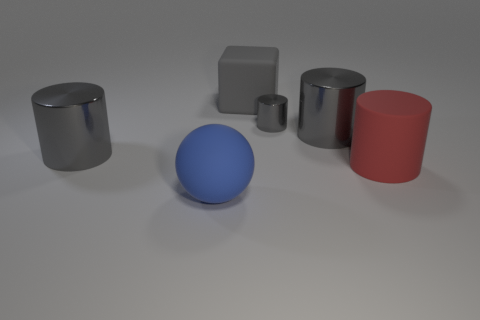Imagine these objects were part of a child's toy set. How would you envision their use? In a child's toy set, these objects could serve multiple purposes. The cylinders and cuboid could be stacked to form towers or used as pillars in a make-believe structure. The blue sphere might be the ball in a game or represent a large body of water in a miniature landscape. The variety of shapes and sizes encourages creativity and could help a child learn about geometry and spatial relationships through play. 